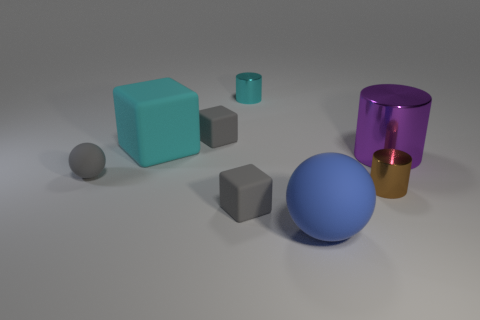Add 1 brown matte balls. How many objects exist? 9 Subtract all tiny gray cubes. How many cubes are left? 1 Subtract all cubes. How many objects are left? 5 Subtract 1 cylinders. How many cylinders are left? 2 Subtract all gray cubes. How many cubes are left? 1 Subtract 1 cyan cubes. How many objects are left? 7 Subtract all yellow balls. Subtract all gray cubes. How many balls are left? 2 Subtract all blue cubes. How many purple spheres are left? 0 Subtract all big purple matte objects. Subtract all brown metal objects. How many objects are left? 7 Add 1 cyan shiny things. How many cyan shiny things are left? 2 